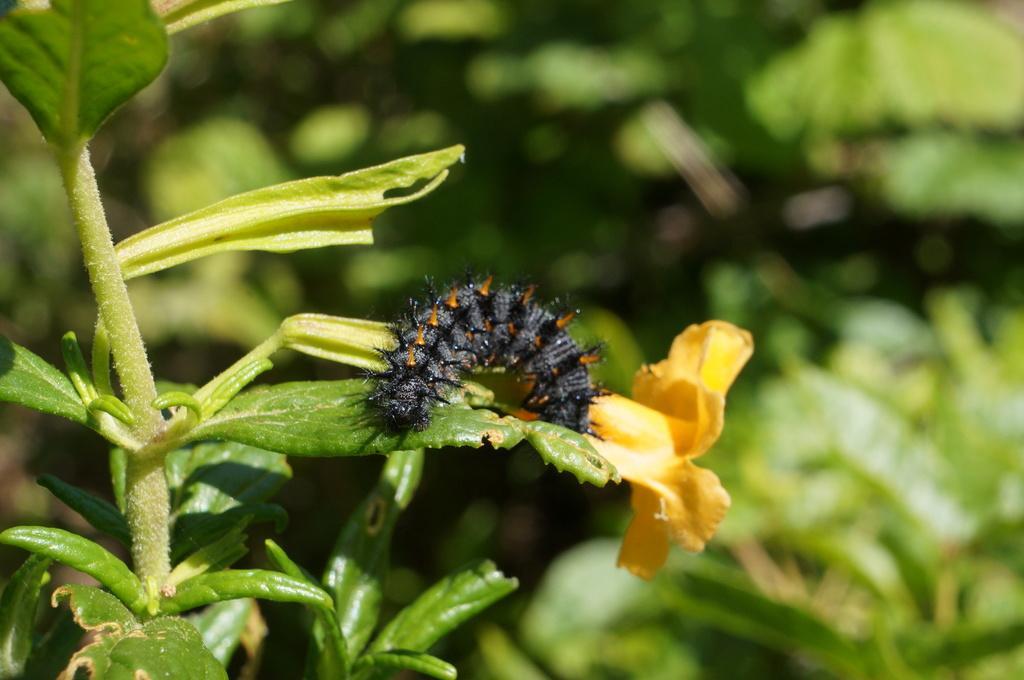In one or two sentences, can you explain what this image depicts? In this image I can see an insect on the leaf and I can see the flower in yellow color. In the background I can see few plants in green color. 